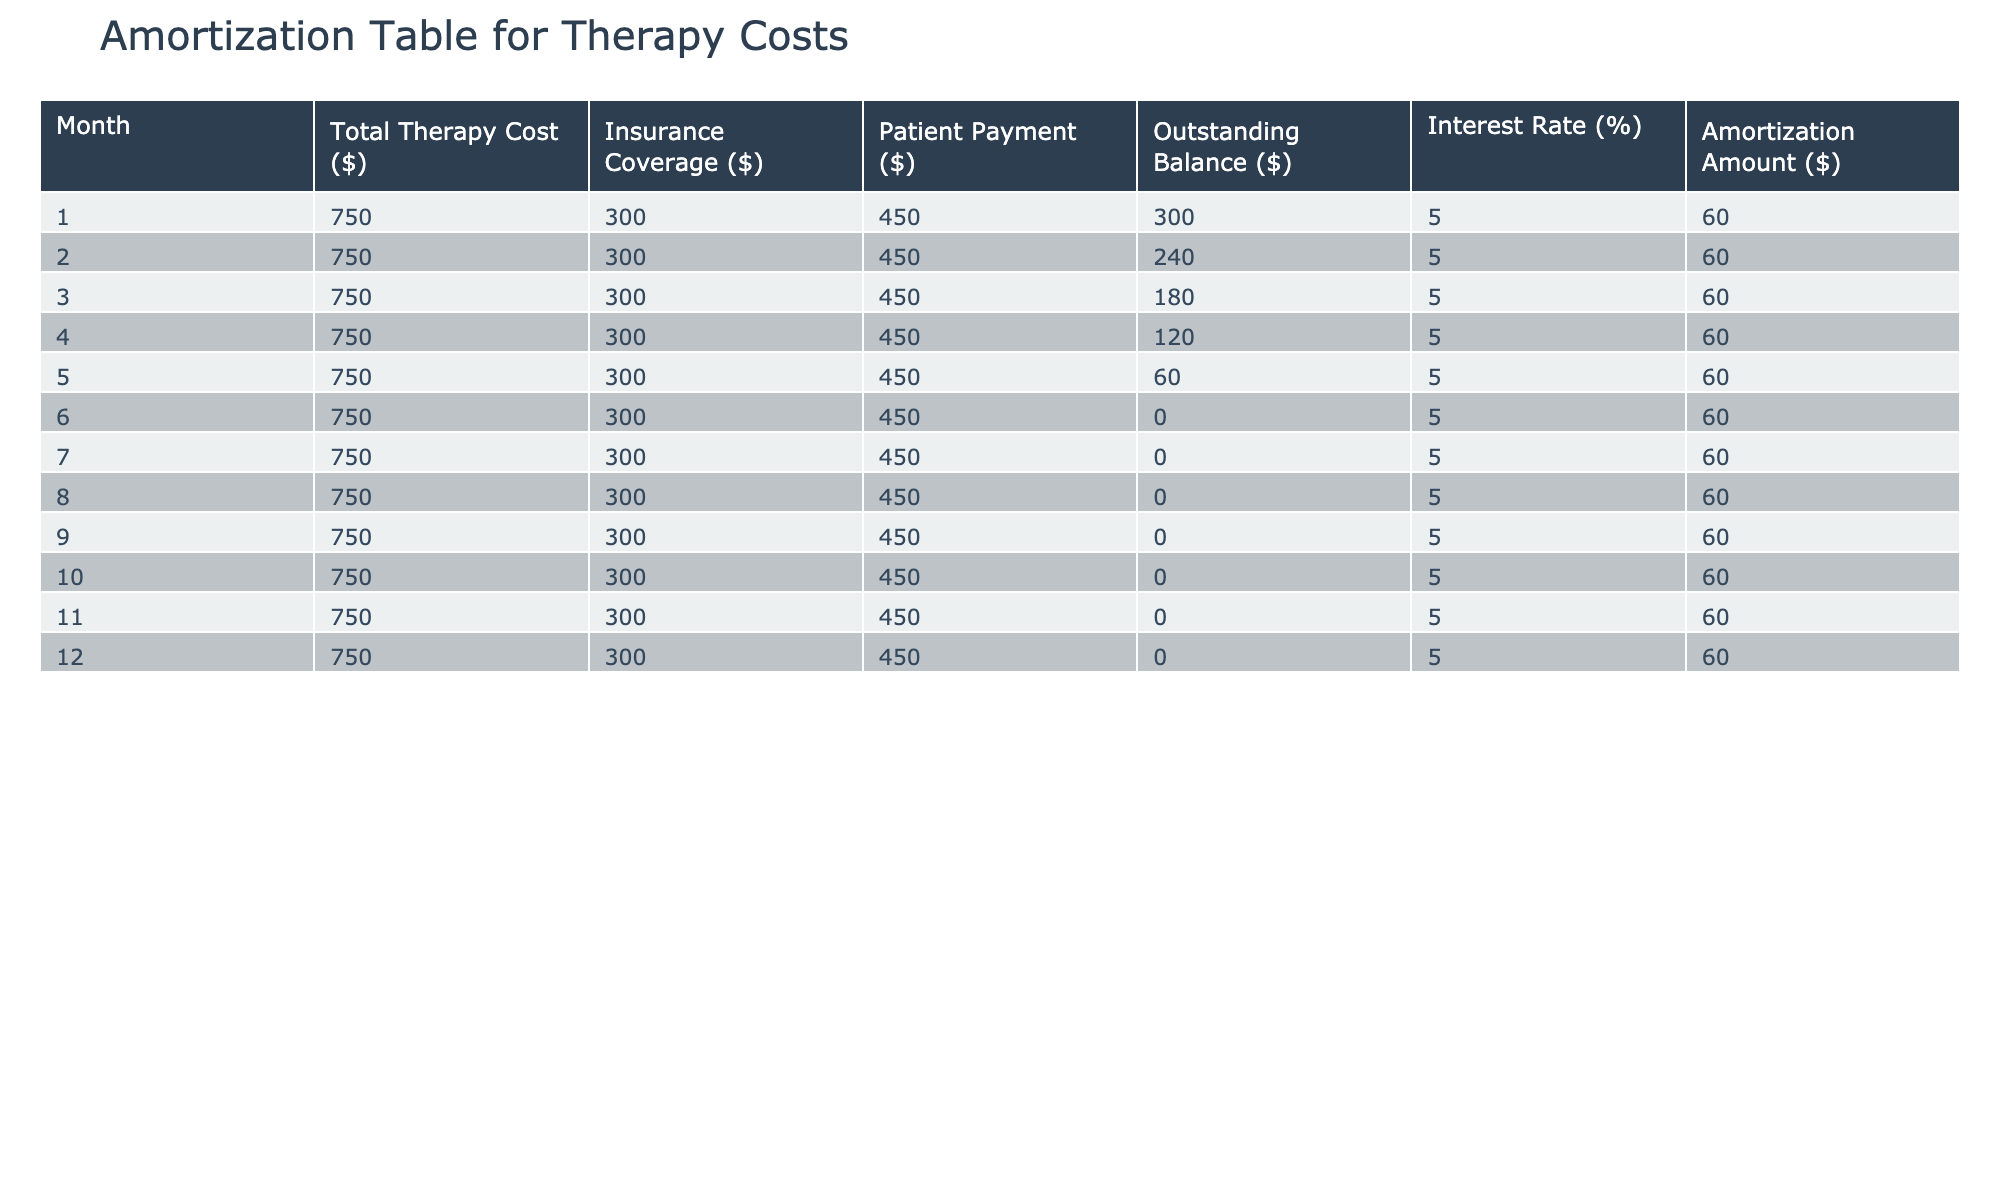What is the total therapy cost for the first month? The total therapy cost for the first month is explicitly listed in the table under the "Total Therapy Cost ($)" column for Month 1, which is 750.
Answer: 750 How much did the patient pay in the second month? The patient payment for the second month can be found in the table under the "Patient Payment ($)" column for Month 2, which is 450.
Answer: 450 What is the outstanding balance after month five? To find the outstanding balance after month five, look at the "Outstanding Balance ($)" column for Month 5, which shows an outstanding balance of 60.
Answer: 60 What is the average patient payment over the first six months? The total patient payments for the first six months can be calculated as follows: 450 + 450 + 450 + 450 + 450 + 450 = 2700. The average is then 2700 / 6 = 450.
Answer: 450 Is the outstanding balance ever negative? The outstanding balance for all months listed in the table is non-negative (0 or positive), as seen in the "Outstanding Balance ($)" column. Therefore, the answer is no.
Answer: No How does the patient payment amount change from month to month? Each month, the patient payment remains constant at 450 dollars. Since there is no variation, there is no change month-over-month.
Answer: No change After month six, what is the outstanding balance through the end of the year? From month six onwards, the outstanding balance is consistently 0, as noted in the "Outstanding Balance ($)" column for all subsequent months (7 through 12).
Answer: 0 How much did the therapy costs decrease in outstanding balance from month one to month six? The outstanding balance at month one is 300 and at month six is 0. The decrease is calculated as 300 - 0 = 300.
Answer: 300 What is the interest rate applied to the therapy costs? The interest rate is consistently provided in the table under the "Interest Rate (%)" column for all months, which is 5.
Answer: 5 